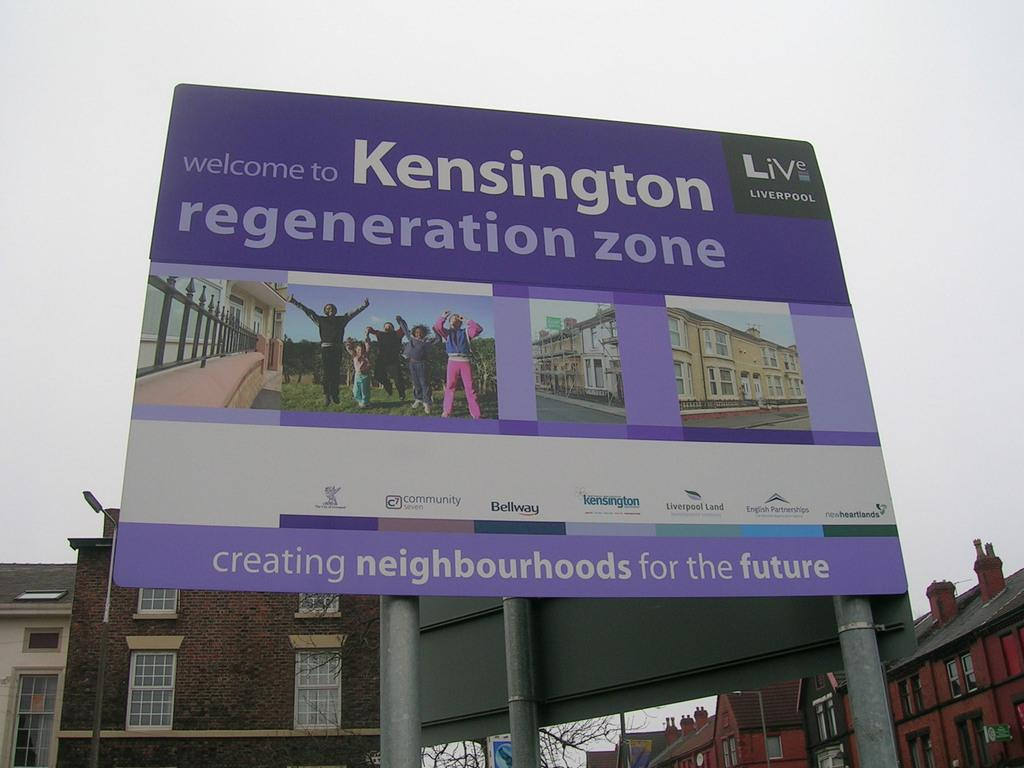<image>
Present a compact description of the photo's key features. A billboard that is promoting Kensington regeneration zone. 